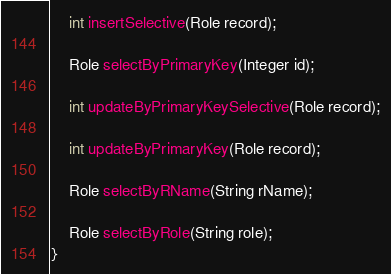<code> <loc_0><loc_0><loc_500><loc_500><_Java_>
    int insertSelective(Role record);

    Role selectByPrimaryKey(Integer id);

    int updateByPrimaryKeySelective(Role record);

    int updateByPrimaryKey(Role record);

    Role selectByRName(String rName);

    Role selectByRole(String role);
}</code> 